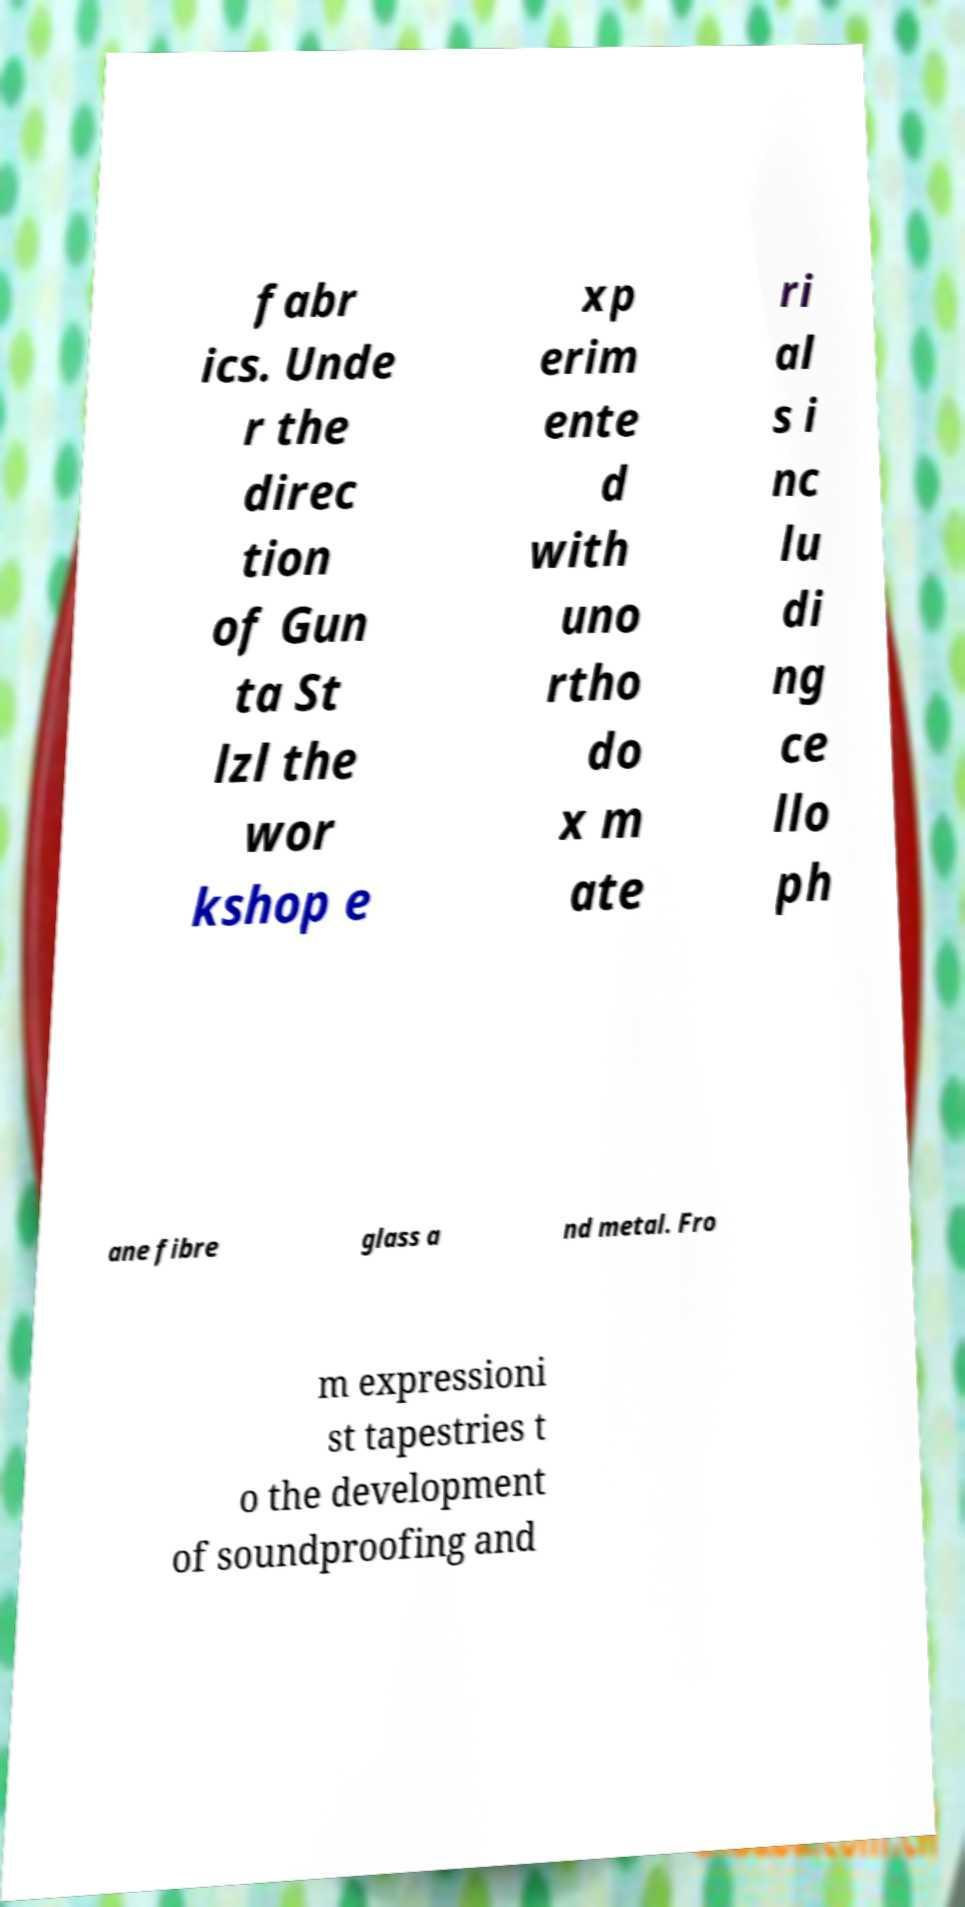Please read and relay the text visible in this image. What does it say? fabr ics. Unde r the direc tion of Gun ta St lzl the wor kshop e xp erim ente d with uno rtho do x m ate ri al s i nc lu di ng ce llo ph ane fibre glass a nd metal. Fro m expressioni st tapestries t o the development of soundproofing and 